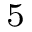Convert formula to latex. <formula><loc_0><loc_0><loc_500><loc_500>_ { 5 }</formula> 